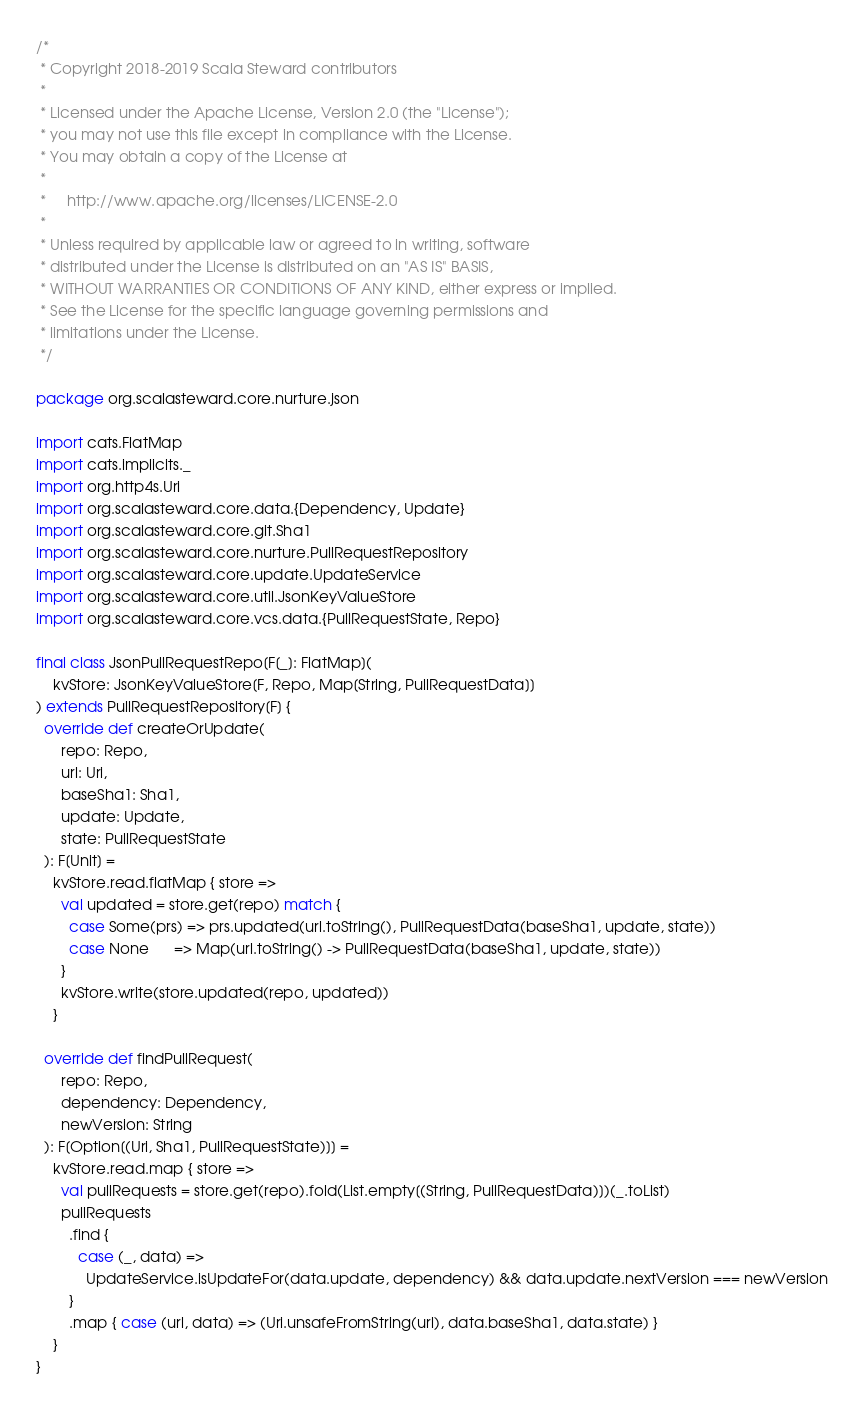<code> <loc_0><loc_0><loc_500><loc_500><_Scala_>/*
 * Copyright 2018-2019 Scala Steward contributors
 *
 * Licensed under the Apache License, Version 2.0 (the "License");
 * you may not use this file except in compliance with the License.
 * You may obtain a copy of the License at
 *
 *     http://www.apache.org/licenses/LICENSE-2.0
 *
 * Unless required by applicable law or agreed to in writing, software
 * distributed under the License is distributed on an "AS IS" BASIS,
 * WITHOUT WARRANTIES OR CONDITIONS OF ANY KIND, either express or implied.
 * See the License for the specific language governing permissions and
 * limitations under the License.
 */

package org.scalasteward.core.nurture.json

import cats.FlatMap
import cats.implicits._
import org.http4s.Uri
import org.scalasteward.core.data.{Dependency, Update}
import org.scalasteward.core.git.Sha1
import org.scalasteward.core.nurture.PullRequestRepository
import org.scalasteward.core.update.UpdateService
import org.scalasteward.core.util.JsonKeyValueStore
import org.scalasteward.core.vcs.data.{PullRequestState, Repo}

final class JsonPullRequestRepo[F[_]: FlatMap](
    kvStore: JsonKeyValueStore[F, Repo, Map[String, PullRequestData]]
) extends PullRequestRepository[F] {
  override def createOrUpdate(
      repo: Repo,
      url: Uri,
      baseSha1: Sha1,
      update: Update,
      state: PullRequestState
  ): F[Unit] =
    kvStore.read.flatMap { store =>
      val updated = store.get(repo) match {
        case Some(prs) => prs.updated(url.toString(), PullRequestData(baseSha1, update, state))
        case None      => Map(url.toString() -> PullRequestData(baseSha1, update, state))
      }
      kvStore.write(store.updated(repo, updated))
    }

  override def findPullRequest(
      repo: Repo,
      dependency: Dependency,
      newVersion: String
  ): F[Option[(Uri, Sha1, PullRequestState)]] =
    kvStore.read.map { store =>
      val pullRequests = store.get(repo).fold(List.empty[(String, PullRequestData)])(_.toList)
      pullRequests
        .find {
          case (_, data) =>
            UpdateService.isUpdateFor(data.update, dependency) && data.update.nextVersion === newVersion
        }
        .map { case (url, data) => (Uri.unsafeFromString(url), data.baseSha1, data.state) }
    }
}
</code> 